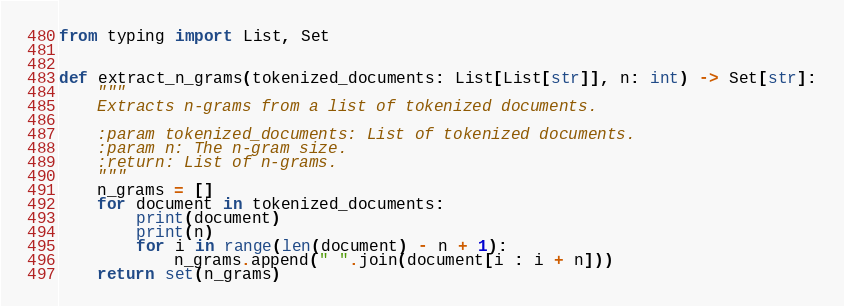<code> <loc_0><loc_0><loc_500><loc_500><_Python_>from typing import List, Set


def extract_n_grams(tokenized_documents: List[List[str]], n: int) -> Set[str]:
    """
    Extracts n-grams from a list of tokenized documents.

    :param tokenized_documents: List of tokenized documents.
    :param n: The n-gram size.
    :return: List of n-grams.
    """
    n_grams = []
    for document in tokenized_documents:
        print(document)
        print(n)
        for i in range(len(document) - n + 1):
            n_grams.append(" ".join(document[i : i + n]))
    return set(n_grams)
</code> 